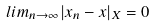<formula> <loc_0><loc_0><loc_500><loc_500>l i m _ { n \rightarrow \infty } | x _ { n } - x | _ { X } = 0</formula> 